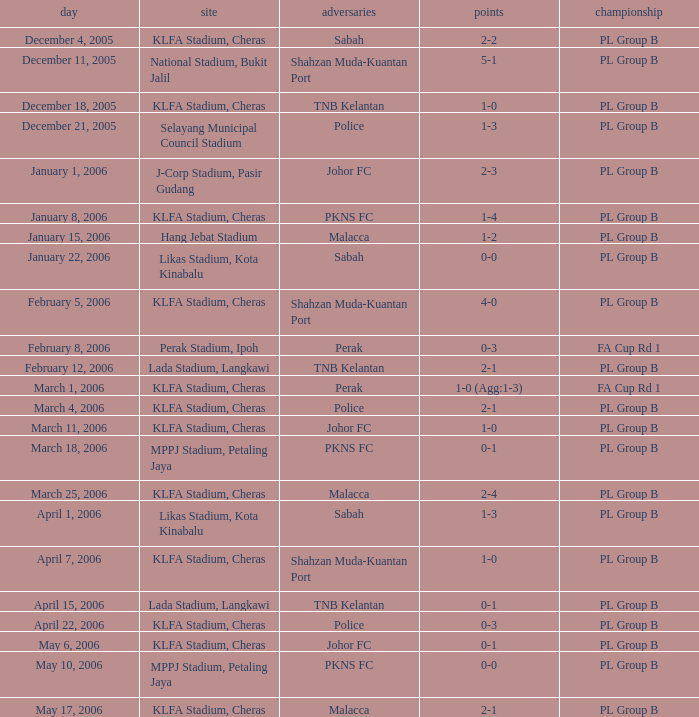Which Competition has Opponents of pkns fc, and a Score of 0-0? PL Group B. 